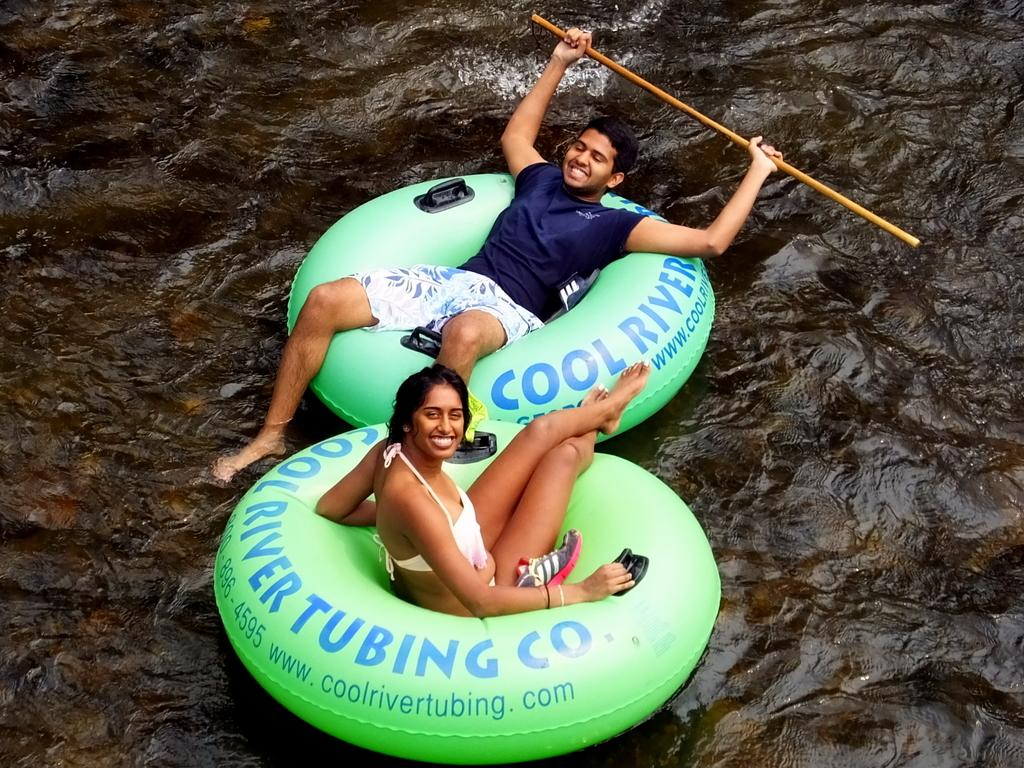How many people are in the image? There are two persons in the image. What are the expressions on their faces? The persons are smiling. What are the persons sitting on in the image? The persons are sitting on inflatable tubes. Where are the inflatable tubes located? The inflatable tubes are on the water. Can you suggest a farm animal that might be present in the image? There are no farm animals present in the image. How many sheep can be seen in the image? There are no sheep present in the image. 